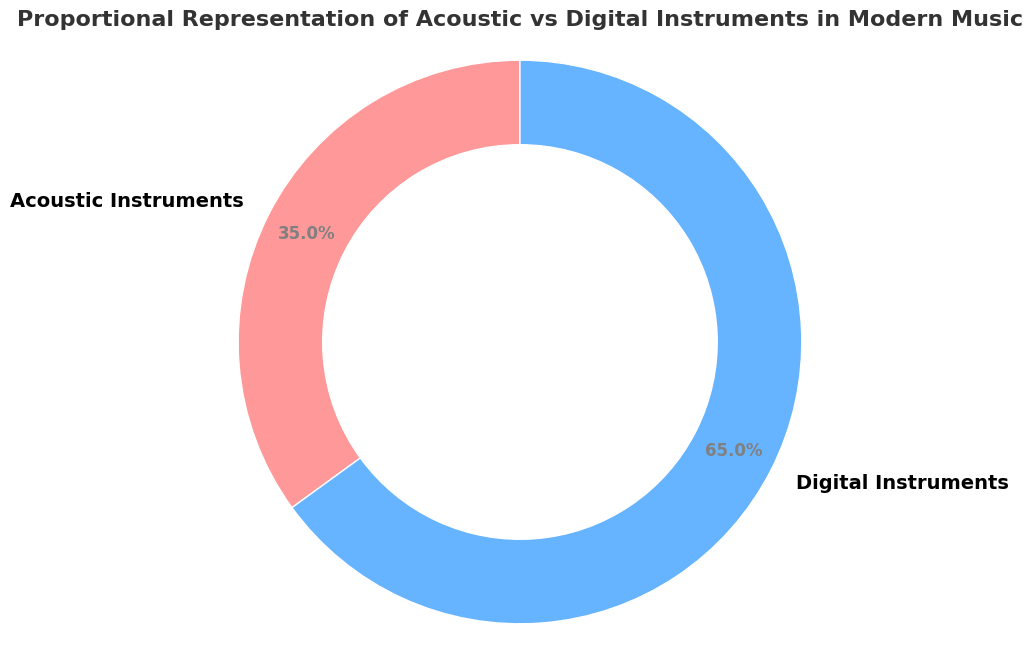What's the proportion of digital instruments represented in modern music? From the ring chart, it's visually clear that the segment representing digital instruments is labeled with 65%, indicating it constitutes 65% of the total representation.
Answer: 65% What's the difference between the percentages of digital and acoustic instruments in modern music? The chart shows that digital instruments represent 65% and acoustic instruments represent 35%. To find the difference, subtract 35 from 65.
Answer: 30% How many times larger is the representation of digital instruments compared to acoustic instruments in modern music? The chart shows 65% for digital and 35% for acoustic instruments. To determine how many times larger the digital representation is, divide 65 by 35.
Answer: About 1.86 times What is the combined percentage of acoustic and digital instruments in modern music? The chart shows 35% for acoustic and 65% for digital. Adding these two values gives 100%, which represents the total.
Answer: 100% What color is used to represent acoustic instruments in the ring chart? Visually, the chart uses two colors. Acoustic instruments are represented by the color closest to red. This can be inferred from the data-to-label associations typical in such charts.
Answer: Red 